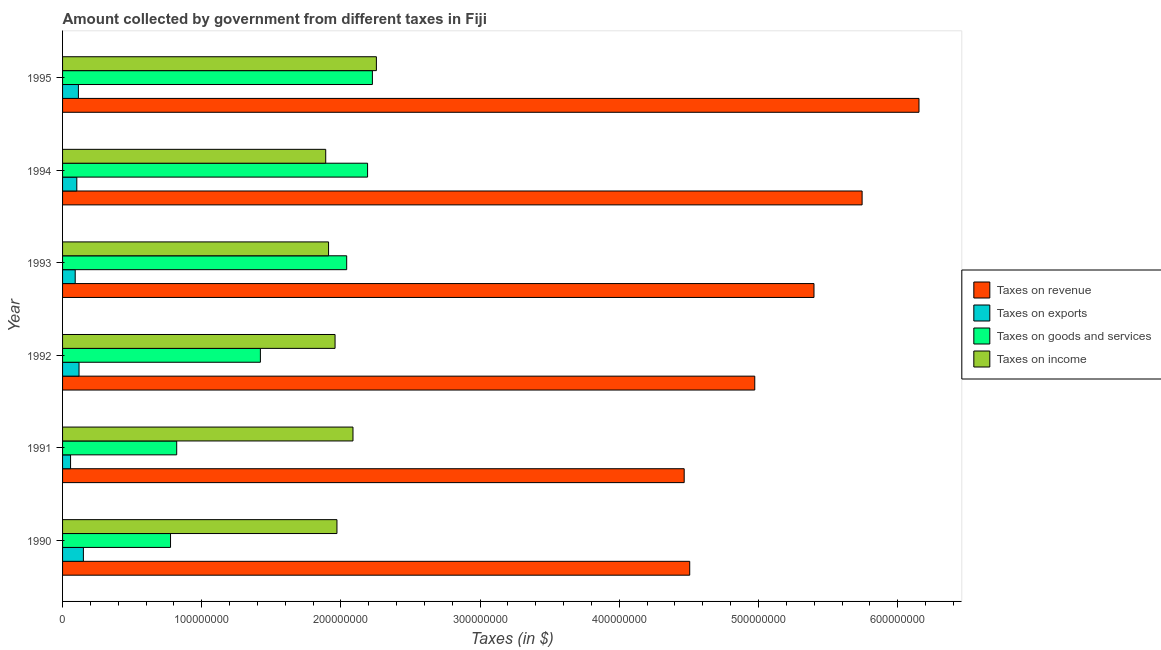How many groups of bars are there?
Offer a very short reply. 6. Are the number of bars on each tick of the Y-axis equal?
Provide a short and direct response. Yes. How many bars are there on the 4th tick from the bottom?
Give a very brief answer. 4. What is the amount collected as tax on exports in 1994?
Give a very brief answer. 1.02e+07. Across all years, what is the maximum amount collected as tax on exports?
Keep it short and to the point. 1.50e+07. Across all years, what is the minimum amount collected as tax on revenue?
Offer a very short reply. 4.47e+08. What is the total amount collected as tax on revenue in the graph?
Provide a succinct answer. 3.12e+09. What is the difference between the amount collected as tax on exports in 1990 and that in 1991?
Ensure brevity in your answer.  9.22e+06. What is the difference between the amount collected as tax on income in 1990 and the amount collected as tax on exports in 1992?
Offer a very short reply. 1.85e+08. What is the average amount collected as tax on goods per year?
Your response must be concise. 1.58e+08. In the year 1995, what is the difference between the amount collected as tax on revenue and amount collected as tax on exports?
Provide a succinct answer. 6.04e+08. What is the ratio of the amount collected as tax on exports in 1990 to that in 1992?
Ensure brevity in your answer.  1.26. Is the difference between the amount collected as tax on goods in 1990 and 1991 greater than the difference between the amount collected as tax on exports in 1990 and 1991?
Your response must be concise. No. What is the difference between the highest and the second highest amount collected as tax on exports?
Offer a very short reply. 3.13e+06. What is the difference between the highest and the lowest amount collected as tax on exports?
Give a very brief answer. 9.22e+06. Is the sum of the amount collected as tax on income in 1990 and 1991 greater than the maximum amount collected as tax on exports across all years?
Your answer should be very brief. Yes. Is it the case that in every year, the sum of the amount collected as tax on income and amount collected as tax on revenue is greater than the sum of amount collected as tax on exports and amount collected as tax on goods?
Your response must be concise. Yes. What does the 4th bar from the top in 1995 represents?
Keep it short and to the point. Taxes on revenue. What does the 3rd bar from the bottom in 1995 represents?
Your response must be concise. Taxes on goods and services. Is it the case that in every year, the sum of the amount collected as tax on revenue and amount collected as tax on exports is greater than the amount collected as tax on goods?
Provide a short and direct response. Yes. Are all the bars in the graph horizontal?
Your answer should be very brief. Yes. Does the graph contain any zero values?
Make the answer very short. No. Does the graph contain grids?
Provide a short and direct response. No. Where does the legend appear in the graph?
Offer a terse response. Center right. How many legend labels are there?
Your response must be concise. 4. How are the legend labels stacked?
Ensure brevity in your answer.  Vertical. What is the title of the graph?
Your response must be concise. Amount collected by government from different taxes in Fiji. What is the label or title of the X-axis?
Provide a succinct answer. Taxes (in $). What is the Taxes (in $) of Taxes on revenue in 1990?
Your response must be concise. 4.51e+08. What is the Taxes (in $) of Taxes on exports in 1990?
Offer a terse response. 1.50e+07. What is the Taxes (in $) of Taxes on goods and services in 1990?
Offer a very short reply. 7.76e+07. What is the Taxes (in $) in Taxes on income in 1990?
Your answer should be very brief. 1.97e+08. What is the Taxes (in $) of Taxes on revenue in 1991?
Offer a terse response. 4.47e+08. What is the Taxes (in $) of Taxes on exports in 1991?
Your answer should be very brief. 5.74e+06. What is the Taxes (in $) of Taxes on goods and services in 1991?
Ensure brevity in your answer.  8.20e+07. What is the Taxes (in $) in Taxes on income in 1991?
Keep it short and to the point. 2.09e+08. What is the Taxes (in $) of Taxes on revenue in 1992?
Provide a short and direct response. 4.97e+08. What is the Taxes (in $) in Taxes on exports in 1992?
Your response must be concise. 1.18e+07. What is the Taxes (in $) of Taxes on goods and services in 1992?
Offer a terse response. 1.42e+08. What is the Taxes (in $) of Taxes on income in 1992?
Give a very brief answer. 1.96e+08. What is the Taxes (in $) of Taxes on revenue in 1993?
Ensure brevity in your answer.  5.40e+08. What is the Taxes (in $) of Taxes on exports in 1993?
Your answer should be compact. 9.08e+06. What is the Taxes (in $) in Taxes on goods and services in 1993?
Keep it short and to the point. 2.04e+08. What is the Taxes (in $) of Taxes on income in 1993?
Provide a short and direct response. 1.91e+08. What is the Taxes (in $) of Taxes on revenue in 1994?
Keep it short and to the point. 5.74e+08. What is the Taxes (in $) in Taxes on exports in 1994?
Your answer should be very brief. 1.02e+07. What is the Taxes (in $) of Taxes on goods and services in 1994?
Your answer should be compact. 2.19e+08. What is the Taxes (in $) of Taxes on income in 1994?
Your response must be concise. 1.89e+08. What is the Taxes (in $) in Taxes on revenue in 1995?
Provide a short and direct response. 6.15e+08. What is the Taxes (in $) of Taxes on exports in 1995?
Ensure brevity in your answer.  1.14e+07. What is the Taxes (in $) in Taxes on goods and services in 1995?
Your answer should be compact. 2.23e+08. What is the Taxes (in $) of Taxes on income in 1995?
Keep it short and to the point. 2.25e+08. Across all years, what is the maximum Taxes (in $) in Taxes on revenue?
Your answer should be very brief. 6.15e+08. Across all years, what is the maximum Taxes (in $) of Taxes on exports?
Ensure brevity in your answer.  1.50e+07. Across all years, what is the maximum Taxes (in $) of Taxes on goods and services?
Your response must be concise. 2.23e+08. Across all years, what is the maximum Taxes (in $) in Taxes on income?
Make the answer very short. 2.25e+08. Across all years, what is the minimum Taxes (in $) in Taxes on revenue?
Offer a very short reply. 4.47e+08. Across all years, what is the minimum Taxes (in $) of Taxes on exports?
Ensure brevity in your answer.  5.74e+06. Across all years, what is the minimum Taxes (in $) of Taxes on goods and services?
Your answer should be compact. 7.76e+07. Across all years, what is the minimum Taxes (in $) in Taxes on income?
Your response must be concise. 1.89e+08. What is the total Taxes (in $) in Taxes on revenue in the graph?
Offer a terse response. 3.12e+09. What is the total Taxes (in $) of Taxes on exports in the graph?
Ensure brevity in your answer.  6.32e+07. What is the total Taxes (in $) of Taxes on goods and services in the graph?
Offer a very short reply. 9.48e+08. What is the total Taxes (in $) of Taxes on income in the graph?
Give a very brief answer. 1.21e+09. What is the difference between the Taxes (in $) of Taxes on revenue in 1990 and that in 1991?
Your answer should be compact. 3.97e+06. What is the difference between the Taxes (in $) in Taxes on exports in 1990 and that in 1991?
Keep it short and to the point. 9.22e+06. What is the difference between the Taxes (in $) in Taxes on goods and services in 1990 and that in 1991?
Provide a succinct answer. -4.43e+06. What is the difference between the Taxes (in $) in Taxes on income in 1990 and that in 1991?
Your answer should be very brief. -1.15e+07. What is the difference between the Taxes (in $) in Taxes on revenue in 1990 and that in 1992?
Your response must be concise. -4.67e+07. What is the difference between the Taxes (in $) in Taxes on exports in 1990 and that in 1992?
Provide a succinct answer. 3.13e+06. What is the difference between the Taxes (in $) of Taxes on goods and services in 1990 and that in 1992?
Your answer should be compact. -6.46e+07. What is the difference between the Taxes (in $) of Taxes on income in 1990 and that in 1992?
Offer a very short reply. 1.36e+06. What is the difference between the Taxes (in $) of Taxes on revenue in 1990 and that in 1993?
Make the answer very short. -8.93e+07. What is the difference between the Taxes (in $) in Taxes on exports in 1990 and that in 1993?
Offer a terse response. 5.88e+06. What is the difference between the Taxes (in $) in Taxes on goods and services in 1990 and that in 1993?
Make the answer very short. -1.27e+08. What is the difference between the Taxes (in $) in Taxes on income in 1990 and that in 1993?
Provide a succinct answer. 6.03e+06. What is the difference between the Taxes (in $) in Taxes on revenue in 1990 and that in 1994?
Your answer should be compact. -1.24e+08. What is the difference between the Taxes (in $) in Taxes on exports in 1990 and that in 1994?
Make the answer very short. 4.72e+06. What is the difference between the Taxes (in $) in Taxes on goods and services in 1990 and that in 1994?
Offer a very short reply. -1.42e+08. What is the difference between the Taxes (in $) in Taxes on income in 1990 and that in 1994?
Provide a succinct answer. 8.07e+06. What is the difference between the Taxes (in $) in Taxes on revenue in 1990 and that in 1995?
Provide a succinct answer. -1.65e+08. What is the difference between the Taxes (in $) in Taxes on exports in 1990 and that in 1995?
Offer a very short reply. 3.58e+06. What is the difference between the Taxes (in $) in Taxes on goods and services in 1990 and that in 1995?
Ensure brevity in your answer.  -1.45e+08. What is the difference between the Taxes (in $) in Taxes on income in 1990 and that in 1995?
Make the answer very short. -2.83e+07. What is the difference between the Taxes (in $) of Taxes on revenue in 1991 and that in 1992?
Provide a succinct answer. -5.07e+07. What is the difference between the Taxes (in $) of Taxes on exports in 1991 and that in 1992?
Your answer should be compact. -6.09e+06. What is the difference between the Taxes (in $) of Taxes on goods and services in 1991 and that in 1992?
Your answer should be very brief. -6.01e+07. What is the difference between the Taxes (in $) in Taxes on income in 1991 and that in 1992?
Provide a succinct answer. 1.29e+07. What is the difference between the Taxes (in $) of Taxes on revenue in 1991 and that in 1993?
Provide a short and direct response. -9.32e+07. What is the difference between the Taxes (in $) of Taxes on exports in 1991 and that in 1993?
Provide a succinct answer. -3.34e+06. What is the difference between the Taxes (in $) of Taxes on goods and services in 1991 and that in 1993?
Your answer should be compact. -1.22e+08. What is the difference between the Taxes (in $) in Taxes on income in 1991 and that in 1993?
Offer a very short reply. 1.76e+07. What is the difference between the Taxes (in $) of Taxes on revenue in 1991 and that in 1994?
Your answer should be compact. -1.28e+08. What is the difference between the Taxes (in $) of Taxes on exports in 1991 and that in 1994?
Your response must be concise. -4.50e+06. What is the difference between the Taxes (in $) in Taxes on goods and services in 1991 and that in 1994?
Give a very brief answer. -1.37e+08. What is the difference between the Taxes (in $) in Taxes on income in 1991 and that in 1994?
Offer a terse response. 1.96e+07. What is the difference between the Taxes (in $) of Taxes on revenue in 1991 and that in 1995?
Make the answer very short. -1.69e+08. What is the difference between the Taxes (in $) of Taxes on exports in 1991 and that in 1995?
Offer a terse response. -5.64e+06. What is the difference between the Taxes (in $) in Taxes on goods and services in 1991 and that in 1995?
Offer a terse response. -1.41e+08. What is the difference between the Taxes (in $) of Taxes on income in 1991 and that in 1995?
Ensure brevity in your answer.  -1.68e+07. What is the difference between the Taxes (in $) in Taxes on revenue in 1992 and that in 1993?
Your answer should be very brief. -4.26e+07. What is the difference between the Taxes (in $) in Taxes on exports in 1992 and that in 1993?
Offer a very short reply. 2.75e+06. What is the difference between the Taxes (in $) in Taxes on goods and services in 1992 and that in 1993?
Make the answer very short. -6.20e+07. What is the difference between the Taxes (in $) in Taxes on income in 1992 and that in 1993?
Offer a very short reply. 4.67e+06. What is the difference between the Taxes (in $) of Taxes on revenue in 1992 and that in 1994?
Offer a terse response. -7.71e+07. What is the difference between the Taxes (in $) in Taxes on exports in 1992 and that in 1994?
Keep it short and to the point. 1.59e+06. What is the difference between the Taxes (in $) of Taxes on goods and services in 1992 and that in 1994?
Offer a very short reply. -7.70e+07. What is the difference between the Taxes (in $) of Taxes on income in 1992 and that in 1994?
Provide a succinct answer. 6.71e+06. What is the difference between the Taxes (in $) of Taxes on revenue in 1992 and that in 1995?
Make the answer very short. -1.18e+08. What is the difference between the Taxes (in $) in Taxes on goods and services in 1992 and that in 1995?
Make the answer very short. -8.05e+07. What is the difference between the Taxes (in $) of Taxes on income in 1992 and that in 1995?
Offer a very short reply. -2.97e+07. What is the difference between the Taxes (in $) in Taxes on revenue in 1993 and that in 1994?
Offer a terse response. -3.46e+07. What is the difference between the Taxes (in $) of Taxes on exports in 1993 and that in 1994?
Give a very brief answer. -1.16e+06. What is the difference between the Taxes (in $) in Taxes on goods and services in 1993 and that in 1994?
Make the answer very short. -1.50e+07. What is the difference between the Taxes (in $) of Taxes on income in 1993 and that in 1994?
Your answer should be compact. 2.04e+06. What is the difference between the Taxes (in $) of Taxes on revenue in 1993 and that in 1995?
Ensure brevity in your answer.  -7.54e+07. What is the difference between the Taxes (in $) in Taxes on exports in 1993 and that in 1995?
Provide a succinct answer. -2.30e+06. What is the difference between the Taxes (in $) in Taxes on goods and services in 1993 and that in 1995?
Provide a succinct answer. -1.85e+07. What is the difference between the Taxes (in $) in Taxes on income in 1993 and that in 1995?
Give a very brief answer. -3.44e+07. What is the difference between the Taxes (in $) in Taxes on revenue in 1994 and that in 1995?
Ensure brevity in your answer.  -4.09e+07. What is the difference between the Taxes (in $) of Taxes on exports in 1994 and that in 1995?
Provide a succinct answer. -1.14e+06. What is the difference between the Taxes (in $) of Taxes on goods and services in 1994 and that in 1995?
Provide a succinct answer. -3.46e+06. What is the difference between the Taxes (in $) of Taxes on income in 1994 and that in 1995?
Offer a terse response. -3.64e+07. What is the difference between the Taxes (in $) of Taxes on revenue in 1990 and the Taxes (in $) of Taxes on exports in 1991?
Offer a very short reply. 4.45e+08. What is the difference between the Taxes (in $) of Taxes on revenue in 1990 and the Taxes (in $) of Taxes on goods and services in 1991?
Give a very brief answer. 3.69e+08. What is the difference between the Taxes (in $) in Taxes on revenue in 1990 and the Taxes (in $) in Taxes on income in 1991?
Offer a very short reply. 2.42e+08. What is the difference between the Taxes (in $) of Taxes on exports in 1990 and the Taxes (in $) of Taxes on goods and services in 1991?
Give a very brief answer. -6.70e+07. What is the difference between the Taxes (in $) of Taxes on exports in 1990 and the Taxes (in $) of Taxes on income in 1991?
Offer a very short reply. -1.94e+08. What is the difference between the Taxes (in $) in Taxes on goods and services in 1990 and the Taxes (in $) in Taxes on income in 1991?
Your answer should be compact. -1.31e+08. What is the difference between the Taxes (in $) in Taxes on revenue in 1990 and the Taxes (in $) in Taxes on exports in 1992?
Make the answer very short. 4.39e+08. What is the difference between the Taxes (in $) of Taxes on revenue in 1990 and the Taxes (in $) of Taxes on goods and services in 1992?
Offer a very short reply. 3.08e+08. What is the difference between the Taxes (in $) in Taxes on revenue in 1990 and the Taxes (in $) in Taxes on income in 1992?
Your answer should be very brief. 2.55e+08. What is the difference between the Taxes (in $) of Taxes on exports in 1990 and the Taxes (in $) of Taxes on goods and services in 1992?
Your answer should be compact. -1.27e+08. What is the difference between the Taxes (in $) of Taxes on exports in 1990 and the Taxes (in $) of Taxes on income in 1992?
Your answer should be very brief. -1.81e+08. What is the difference between the Taxes (in $) in Taxes on goods and services in 1990 and the Taxes (in $) in Taxes on income in 1992?
Ensure brevity in your answer.  -1.18e+08. What is the difference between the Taxes (in $) of Taxes on revenue in 1990 and the Taxes (in $) of Taxes on exports in 1993?
Give a very brief answer. 4.42e+08. What is the difference between the Taxes (in $) of Taxes on revenue in 1990 and the Taxes (in $) of Taxes on goods and services in 1993?
Make the answer very short. 2.46e+08. What is the difference between the Taxes (in $) of Taxes on revenue in 1990 and the Taxes (in $) of Taxes on income in 1993?
Your response must be concise. 2.59e+08. What is the difference between the Taxes (in $) in Taxes on exports in 1990 and the Taxes (in $) in Taxes on goods and services in 1993?
Give a very brief answer. -1.89e+08. What is the difference between the Taxes (in $) in Taxes on exports in 1990 and the Taxes (in $) in Taxes on income in 1993?
Your answer should be compact. -1.76e+08. What is the difference between the Taxes (in $) of Taxes on goods and services in 1990 and the Taxes (in $) of Taxes on income in 1993?
Make the answer very short. -1.14e+08. What is the difference between the Taxes (in $) in Taxes on revenue in 1990 and the Taxes (in $) in Taxes on exports in 1994?
Provide a short and direct response. 4.40e+08. What is the difference between the Taxes (in $) of Taxes on revenue in 1990 and the Taxes (in $) of Taxes on goods and services in 1994?
Keep it short and to the point. 2.31e+08. What is the difference between the Taxes (in $) in Taxes on revenue in 1990 and the Taxes (in $) in Taxes on income in 1994?
Provide a succinct answer. 2.62e+08. What is the difference between the Taxes (in $) of Taxes on exports in 1990 and the Taxes (in $) of Taxes on goods and services in 1994?
Make the answer very short. -2.04e+08. What is the difference between the Taxes (in $) of Taxes on exports in 1990 and the Taxes (in $) of Taxes on income in 1994?
Your answer should be very brief. -1.74e+08. What is the difference between the Taxes (in $) in Taxes on goods and services in 1990 and the Taxes (in $) in Taxes on income in 1994?
Keep it short and to the point. -1.12e+08. What is the difference between the Taxes (in $) of Taxes on revenue in 1990 and the Taxes (in $) of Taxes on exports in 1995?
Your answer should be compact. 4.39e+08. What is the difference between the Taxes (in $) in Taxes on revenue in 1990 and the Taxes (in $) in Taxes on goods and services in 1995?
Provide a short and direct response. 2.28e+08. What is the difference between the Taxes (in $) in Taxes on revenue in 1990 and the Taxes (in $) in Taxes on income in 1995?
Provide a short and direct response. 2.25e+08. What is the difference between the Taxes (in $) of Taxes on exports in 1990 and the Taxes (in $) of Taxes on goods and services in 1995?
Provide a succinct answer. -2.08e+08. What is the difference between the Taxes (in $) of Taxes on exports in 1990 and the Taxes (in $) of Taxes on income in 1995?
Make the answer very short. -2.11e+08. What is the difference between the Taxes (in $) of Taxes on goods and services in 1990 and the Taxes (in $) of Taxes on income in 1995?
Provide a succinct answer. -1.48e+08. What is the difference between the Taxes (in $) of Taxes on revenue in 1991 and the Taxes (in $) of Taxes on exports in 1992?
Provide a short and direct response. 4.35e+08. What is the difference between the Taxes (in $) of Taxes on revenue in 1991 and the Taxes (in $) of Taxes on goods and services in 1992?
Offer a very short reply. 3.04e+08. What is the difference between the Taxes (in $) of Taxes on revenue in 1991 and the Taxes (in $) of Taxes on income in 1992?
Your answer should be compact. 2.51e+08. What is the difference between the Taxes (in $) in Taxes on exports in 1991 and the Taxes (in $) in Taxes on goods and services in 1992?
Provide a succinct answer. -1.36e+08. What is the difference between the Taxes (in $) in Taxes on exports in 1991 and the Taxes (in $) in Taxes on income in 1992?
Keep it short and to the point. -1.90e+08. What is the difference between the Taxes (in $) in Taxes on goods and services in 1991 and the Taxes (in $) in Taxes on income in 1992?
Your response must be concise. -1.14e+08. What is the difference between the Taxes (in $) in Taxes on revenue in 1991 and the Taxes (in $) in Taxes on exports in 1993?
Provide a short and direct response. 4.38e+08. What is the difference between the Taxes (in $) of Taxes on revenue in 1991 and the Taxes (in $) of Taxes on goods and services in 1993?
Your response must be concise. 2.42e+08. What is the difference between the Taxes (in $) of Taxes on revenue in 1991 and the Taxes (in $) of Taxes on income in 1993?
Make the answer very short. 2.56e+08. What is the difference between the Taxes (in $) of Taxes on exports in 1991 and the Taxes (in $) of Taxes on goods and services in 1993?
Keep it short and to the point. -1.98e+08. What is the difference between the Taxes (in $) of Taxes on exports in 1991 and the Taxes (in $) of Taxes on income in 1993?
Offer a very short reply. -1.85e+08. What is the difference between the Taxes (in $) of Taxes on goods and services in 1991 and the Taxes (in $) of Taxes on income in 1993?
Ensure brevity in your answer.  -1.09e+08. What is the difference between the Taxes (in $) in Taxes on revenue in 1991 and the Taxes (in $) in Taxes on exports in 1994?
Your answer should be compact. 4.36e+08. What is the difference between the Taxes (in $) of Taxes on revenue in 1991 and the Taxes (in $) of Taxes on goods and services in 1994?
Your answer should be compact. 2.27e+08. What is the difference between the Taxes (in $) of Taxes on revenue in 1991 and the Taxes (in $) of Taxes on income in 1994?
Give a very brief answer. 2.58e+08. What is the difference between the Taxes (in $) of Taxes on exports in 1991 and the Taxes (in $) of Taxes on goods and services in 1994?
Give a very brief answer. -2.13e+08. What is the difference between the Taxes (in $) of Taxes on exports in 1991 and the Taxes (in $) of Taxes on income in 1994?
Provide a short and direct response. -1.83e+08. What is the difference between the Taxes (in $) of Taxes on goods and services in 1991 and the Taxes (in $) of Taxes on income in 1994?
Ensure brevity in your answer.  -1.07e+08. What is the difference between the Taxes (in $) of Taxes on revenue in 1991 and the Taxes (in $) of Taxes on exports in 1995?
Give a very brief answer. 4.35e+08. What is the difference between the Taxes (in $) of Taxes on revenue in 1991 and the Taxes (in $) of Taxes on goods and services in 1995?
Give a very brief answer. 2.24e+08. What is the difference between the Taxes (in $) of Taxes on revenue in 1991 and the Taxes (in $) of Taxes on income in 1995?
Keep it short and to the point. 2.21e+08. What is the difference between the Taxes (in $) in Taxes on exports in 1991 and the Taxes (in $) in Taxes on goods and services in 1995?
Your answer should be compact. -2.17e+08. What is the difference between the Taxes (in $) in Taxes on exports in 1991 and the Taxes (in $) in Taxes on income in 1995?
Provide a short and direct response. -2.20e+08. What is the difference between the Taxes (in $) of Taxes on goods and services in 1991 and the Taxes (in $) of Taxes on income in 1995?
Your answer should be compact. -1.43e+08. What is the difference between the Taxes (in $) of Taxes on revenue in 1992 and the Taxes (in $) of Taxes on exports in 1993?
Provide a succinct answer. 4.88e+08. What is the difference between the Taxes (in $) of Taxes on revenue in 1992 and the Taxes (in $) of Taxes on goods and services in 1993?
Offer a terse response. 2.93e+08. What is the difference between the Taxes (in $) in Taxes on revenue in 1992 and the Taxes (in $) in Taxes on income in 1993?
Ensure brevity in your answer.  3.06e+08. What is the difference between the Taxes (in $) of Taxes on exports in 1992 and the Taxes (in $) of Taxes on goods and services in 1993?
Ensure brevity in your answer.  -1.92e+08. What is the difference between the Taxes (in $) in Taxes on exports in 1992 and the Taxes (in $) in Taxes on income in 1993?
Your answer should be compact. -1.79e+08. What is the difference between the Taxes (in $) in Taxes on goods and services in 1992 and the Taxes (in $) in Taxes on income in 1993?
Keep it short and to the point. -4.90e+07. What is the difference between the Taxes (in $) in Taxes on revenue in 1992 and the Taxes (in $) in Taxes on exports in 1994?
Provide a short and direct response. 4.87e+08. What is the difference between the Taxes (in $) of Taxes on revenue in 1992 and the Taxes (in $) of Taxes on goods and services in 1994?
Make the answer very short. 2.78e+08. What is the difference between the Taxes (in $) in Taxes on revenue in 1992 and the Taxes (in $) in Taxes on income in 1994?
Your answer should be very brief. 3.08e+08. What is the difference between the Taxes (in $) of Taxes on exports in 1992 and the Taxes (in $) of Taxes on goods and services in 1994?
Ensure brevity in your answer.  -2.07e+08. What is the difference between the Taxes (in $) in Taxes on exports in 1992 and the Taxes (in $) in Taxes on income in 1994?
Offer a terse response. -1.77e+08. What is the difference between the Taxes (in $) in Taxes on goods and services in 1992 and the Taxes (in $) in Taxes on income in 1994?
Ensure brevity in your answer.  -4.69e+07. What is the difference between the Taxes (in $) of Taxes on revenue in 1992 and the Taxes (in $) of Taxes on exports in 1995?
Offer a terse response. 4.86e+08. What is the difference between the Taxes (in $) of Taxes on revenue in 1992 and the Taxes (in $) of Taxes on goods and services in 1995?
Offer a very short reply. 2.75e+08. What is the difference between the Taxes (in $) in Taxes on revenue in 1992 and the Taxes (in $) in Taxes on income in 1995?
Give a very brief answer. 2.72e+08. What is the difference between the Taxes (in $) in Taxes on exports in 1992 and the Taxes (in $) in Taxes on goods and services in 1995?
Your answer should be compact. -2.11e+08. What is the difference between the Taxes (in $) of Taxes on exports in 1992 and the Taxes (in $) of Taxes on income in 1995?
Ensure brevity in your answer.  -2.14e+08. What is the difference between the Taxes (in $) in Taxes on goods and services in 1992 and the Taxes (in $) in Taxes on income in 1995?
Offer a very short reply. -8.33e+07. What is the difference between the Taxes (in $) of Taxes on revenue in 1993 and the Taxes (in $) of Taxes on exports in 1994?
Your response must be concise. 5.30e+08. What is the difference between the Taxes (in $) in Taxes on revenue in 1993 and the Taxes (in $) in Taxes on goods and services in 1994?
Ensure brevity in your answer.  3.21e+08. What is the difference between the Taxes (in $) of Taxes on revenue in 1993 and the Taxes (in $) of Taxes on income in 1994?
Offer a terse response. 3.51e+08. What is the difference between the Taxes (in $) in Taxes on exports in 1993 and the Taxes (in $) in Taxes on goods and services in 1994?
Provide a succinct answer. -2.10e+08. What is the difference between the Taxes (in $) in Taxes on exports in 1993 and the Taxes (in $) in Taxes on income in 1994?
Provide a succinct answer. -1.80e+08. What is the difference between the Taxes (in $) of Taxes on goods and services in 1993 and the Taxes (in $) of Taxes on income in 1994?
Your answer should be compact. 1.51e+07. What is the difference between the Taxes (in $) of Taxes on revenue in 1993 and the Taxes (in $) of Taxes on exports in 1995?
Offer a terse response. 5.28e+08. What is the difference between the Taxes (in $) in Taxes on revenue in 1993 and the Taxes (in $) in Taxes on goods and services in 1995?
Your answer should be compact. 3.17e+08. What is the difference between the Taxes (in $) in Taxes on revenue in 1993 and the Taxes (in $) in Taxes on income in 1995?
Keep it short and to the point. 3.14e+08. What is the difference between the Taxes (in $) in Taxes on exports in 1993 and the Taxes (in $) in Taxes on goods and services in 1995?
Offer a terse response. -2.14e+08. What is the difference between the Taxes (in $) in Taxes on exports in 1993 and the Taxes (in $) in Taxes on income in 1995?
Your answer should be compact. -2.16e+08. What is the difference between the Taxes (in $) of Taxes on goods and services in 1993 and the Taxes (in $) of Taxes on income in 1995?
Keep it short and to the point. -2.13e+07. What is the difference between the Taxes (in $) of Taxes on revenue in 1994 and the Taxes (in $) of Taxes on exports in 1995?
Ensure brevity in your answer.  5.63e+08. What is the difference between the Taxes (in $) in Taxes on revenue in 1994 and the Taxes (in $) in Taxes on goods and services in 1995?
Offer a terse response. 3.52e+08. What is the difference between the Taxes (in $) in Taxes on revenue in 1994 and the Taxes (in $) in Taxes on income in 1995?
Keep it short and to the point. 3.49e+08. What is the difference between the Taxes (in $) in Taxes on exports in 1994 and the Taxes (in $) in Taxes on goods and services in 1995?
Ensure brevity in your answer.  -2.12e+08. What is the difference between the Taxes (in $) of Taxes on exports in 1994 and the Taxes (in $) of Taxes on income in 1995?
Your response must be concise. -2.15e+08. What is the difference between the Taxes (in $) of Taxes on goods and services in 1994 and the Taxes (in $) of Taxes on income in 1995?
Your answer should be compact. -6.33e+06. What is the average Taxes (in $) in Taxes on revenue per year?
Give a very brief answer. 5.21e+08. What is the average Taxes (in $) of Taxes on exports per year?
Offer a terse response. 1.05e+07. What is the average Taxes (in $) of Taxes on goods and services per year?
Give a very brief answer. 1.58e+08. What is the average Taxes (in $) in Taxes on income per year?
Offer a terse response. 2.01e+08. In the year 1990, what is the difference between the Taxes (in $) in Taxes on revenue and Taxes (in $) in Taxes on exports?
Provide a short and direct response. 4.36e+08. In the year 1990, what is the difference between the Taxes (in $) of Taxes on revenue and Taxes (in $) of Taxes on goods and services?
Your answer should be very brief. 3.73e+08. In the year 1990, what is the difference between the Taxes (in $) of Taxes on revenue and Taxes (in $) of Taxes on income?
Your answer should be compact. 2.53e+08. In the year 1990, what is the difference between the Taxes (in $) in Taxes on exports and Taxes (in $) in Taxes on goods and services?
Your answer should be very brief. -6.26e+07. In the year 1990, what is the difference between the Taxes (in $) in Taxes on exports and Taxes (in $) in Taxes on income?
Offer a terse response. -1.82e+08. In the year 1990, what is the difference between the Taxes (in $) of Taxes on goods and services and Taxes (in $) of Taxes on income?
Make the answer very short. -1.20e+08. In the year 1991, what is the difference between the Taxes (in $) in Taxes on revenue and Taxes (in $) in Taxes on exports?
Offer a terse response. 4.41e+08. In the year 1991, what is the difference between the Taxes (in $) of Taxes on revenue and Taxes (in $) of Taxes on goods and services?
Keep it short and to the point. 3.65e+08. In the year 1991, what is the difference between the Taxes (in $) in Taxes on revenue and Taxes (in $) in Taxes on income?
Your answer should be compact. 2.38e+08. In the year 1991, what is the difference between the Taxes (in $) in Taxes on exports and Taxes (in $) in Taxes on goods and services?
Ensure brevity in your answer.  -7.63e+07. In the year 1991, what is the difference between the Taxes (in $) in Taxes on exports and Taxes (in $) in Taxes on income?
Provide a short and direct response. -2.03e+08. In the year 1991, what is the difference between the Taxes (in $) of Taxes on goods and services and Taxes (in $) of Taxes on income?
Offer a terse response. -1.27e+08. In the year 1992, what is the difference between the Taxes (in $) in Taxes on revenue and Taxes (in $) in Taxes on exports?
Your answer should be compact. 4.85e+08. In the year 1992, what is the difference between the Taxes (in $) in Taxes on revenue and Taxes (in $) in Taxes on goods and services?
Keep it short and to the point. 3.55e+08. In the year 1992, what is the difference between the Taxes (in $) in Taxes on revenue and Taxes (in $) in Taxes on income?
Your answer should be compact. 3.02e+08. In the year 1992, what is the difference between the Taxes (in $) in Taxes on exports and Taxes (in $) in Taxes on goods and services?
Give a very brief answer. -1.30e+08. In the year 1992, what is the difference between the Taxes (in $) of Taxes on exports and Taxes (in $) of Taxes on income?
Keep it short and to the point. -1.84e+08. In the year 1992, what is the difference between the Taxes (in $) in Taxes on goods and services and Taxes (in $) in Taxes on income?
Your answer should be compact. -5.36e+07. In the year 1993, what is the difference between the Taxes (in $) of Taxes on revenue and Taxes (in $) of Taxes on exports?
Ensure brevity in your answer.  5.31e+08. In the year 1993, what is the difference between the Taxes (in $) of Taxes on revenue and Taxes (in $) of Taxes on goods and services?
Offer a very short reply. 3.36e+08. In the year 1993, what is the difference between the Taxes (in $) of Taxes on revenue and Taxes (in $) of Taxes on income?
Provide a succinct answer. 3.49e+08. In the year 1993, what is the difference between the Taxes (in $) of Taxes on exports and Taxes (in $) of Taxes on goods and services?
Your answer should be very brief. -1.95e+08. In the year 1993, what is the difference between the Taxes (in $) of Taxes on exports and Taxes (in $) of Taxes on income?
Your answer should be very brief. -1.82e+08. In the year 1993, what is the difference between the Taxes (in $) of Taxes on goods and services and Taxes (in $) of Taxes on income?
Make the answer very short. 1.30e+07. In the year 1994, what is the difference between the Taxes (in $) in Taxes on revenue and Taxes (in $) in Taxes on exports?
Keep it short and to the point. 5.64e+08. In the year 1994, what is the difference between the Taxes (in $) of Taxes on revenue and Taxes (in $) of Taxes on goods and services?
Offer a terse response. 3.55e+08. In the year 1994, what is the difference between the Taxes (in $) of Taxes on revenue and Taxes (in $) of Taxes on income?
Your answer should be compact. 3.85e+08. In the year 1994, what is the difference between the Taxes (in $) in Taxes on exports and Taxes (in $) in Taxes on goods and services?
Your answer should be very brief. -2.09e+08. In the year 1994, what is the difference between the Taxes (in $) in Taxes on exports and Taxes (in $) in Taxes on income?
Your response must be concise. -1.79e+08. In the year 1994, what is the difference between the Taxes (in $) in Taxes on goods and services and Taxes (in $) in Taxes on income?
Give a very brief answer. 3.01e+07. In the year 1995, what is the difference between the Taxes (in $) in Taxes on revenue and Taxes (in $) in Taxes on exports?
Give a very brief answer. 6.04e+08. In the year 1995, what is the difference between the Taxes (in $) in Taxes on revenue and Taxes (in $) in Taxes on goods and services?
Make the answer very short. 3.93e+08. In the year 1995, what is the difference between the Taxes (in $) in Taxes on revenue and Taxes (in $) in Taxes on income?
Ensure brevity in your answer.  3.90e+08. In the year 1995, what is the difference between the Taxes (in $) in Taxes on exports and Taxes (in $) in Taxes on goods and services?
Offer a terse response. -2.11e+08. In the year 1995, what is the difference between the Taxes (in $) of Taxes on exports and Taxes (in $) of Taxes on income?
Your answer should be very brief. -2.14e+08. In the year 1995, what is the difference between the Taxes (in $) in Taxes on goods and services and Taxes (in $) in Taxes on income?
Make the answer very short. -2.87e+06. What is the ratio of the Taxes (in $) in Taxes on revenue in 1990 to that in 1991?
Give a very brief answer. 1.01. What is the ratio of the Taxes (in $) of Taxes on exports in 1990 to that in 1991?
Your answer should be very brief. 2.61. What is the ratio of the Taxes (in $) in Taxes on goods and services in 1990 to that in 1991?
Provide a short and direct response. 0.95. What is the ratio of the Taxes (in $) of Taxes on income in 1990 to that in 1991?
Keep it short and to the point. 0.94. What is the ratio of the Taxes (in $) of Taxes on revenue in 1990 to that in 1992?
Provide a short and direct response. 0.91. What is the ratio of the Taxes (in $) of Taxes on exports in 1990 to that in 1992?
Ensure brevity in your answer.  1.26. What is the ratio of the Taxes (in $) in Taxes on goods and services in 1990 to that in 1992?
Your answer should be compact. 0.55. What is the ratio of the Taxes (in $) in Taxes on revenue in 1990 to that in 1993?
Offer a terse response. 0.83. What is the ratio of the Taxes (in $) in Taxes on exports in 1990 to that in 1993?
Provide a succinct answer. 1.65. What is the ratio of the Taxes (in $) of Taxes on goods and services in 1990 to that in 1993?
Your response must be concise. 0.38. What is the ratio of the Taxes (in $) of Taxes on income in 1990 to that in 1993?
Offer a terse response. 1.03. What is the ratio of the Taxes (in $) in Taxes on revenue in 1990 to that in 1994?
Keep it short and to the point. 0.78. What is the ratio of the Taxes (in $) of Taxes on exports in 1990 to that in 1994?
Your response must be concise. 1.46. What is the ratio of the Taxes (in $) in Taxes on goods and services in 1990 to that in 1994?
Give a very brief answer. 0.35. What is the ratio of the Taxes (in $) in Taxes on income in 1990 to that in 1994?
Offer a terse response. 1.04. What is the ratio of the Taxes (in $) in Taxes on revenue in 1990 to that in 1995?
Offer a terse response. 0.73. What is the ratio of the Taxes (in $) of Taxes on exports in 1990 to that in 1995?
Provide a succinct answer. 1.31. What is the ratio of the Taxes (in $) of Taxes on goods and services in 1990 to that in 1995?
Keep it short and to the point. 0.35. What is the ratio of the Taxes (in $) of Taxes on income in 1990 to that in 1995?
Keep it short and to the point. 0.87. What is the ratio of the Taxes (in $) in Taxes on revenue in 1991 to that in 1992?
Make the answer very short. 0.9. What is the ratio of the Taxes (in $) of Taxes on exports in 1991 to that in 1992?
Your answer should be compact. 0.49. What is the ratio of the Taxes (in $) in Taxes on goods and services in 1991 to that in 1992?
Offer a very short reply. 0.58. What is the ratio of the Taxes (in $) in Taxes on income in 1991 to that in 1992?
Provide a short and direct response. 1.07. What is the ratio of the Taxes (in $) of Taxes on revenue in 1991 to that in 1993?
Ensure brevity in your answer.  0.83. What is the ratio of the Taxes (in $) in Taxes on exports in 1991 to that in 1993?
Your answer should be very brief. 0.63. What is the ratio of the Taxes (in $) of Taxes on goods and services in 1991 to that in 1993?
Keep it short and to the point. 0.4. What is the ratio of the Taxes (in $) in Taxes on income in 1991 to that in 1993?
Your answer should be compact. 1.09. What is the ratio of the Taxes (in $) of Taxes on revenue in 1991 to that in 1994?
Offer a terse response. 0.78. What is the ratio of the Taxes (in $) in Taxes on exports in 1991 to that in 1994?
Your answer should be compact. 0.56. What is the ratio of the Taxes (in $) of Taxes on goods and services in 1991 to that in 1994?
Offer a terse response. 0.37. What is the ratio of the Taxes (in $) in Taxes on income in 1991 to that in 1994?
Your answer should be very brief. 1.1. What is the ratio of the Taxes (in $) in Taxes on revenue in 1991 to that in 1995?
Provide a short and direct response. 0.73. What is the ratio of the Taxes (in $) in Taxes on exports in 1991 to that in 1995?
Your response must be concise. 0.5. What is the ratio of the Taxes (in $) of Taxes on goods and services in 1991 to that in 1995?
Offer a terse response. 0.37. What is the ratio of the Taxes (in $) of Taxes on income in 1991 to that in 1995?
Your answer should be compact. 0.93. What is the ratio of the Taxes (in $) in Taxes on revenue in 1992 to that in 1993?
Ensure brevity in your answer.  0.92. What is the ratio of the Taxes (in $) in Taxes on exports in 1992 to that in 1993?
Your response must be concise. 1.3. What is the ratio of the Taxes (in $) of Taxes on goods and services in 1992 to that in 1993?
Keep it short and to the point. 0.7. What is the ratio of the Taxes (in $) of Taxes on income in 1992 to that in 1993?
Provide a succinct answer. 1.02. What is the ratio of the Taxes (in $) of Taxes on revenue in 1992 to that in 1994?
Give a very brief answer. 0.87. What is the ratio of the Taxes (in $) in Taxes on exports in 1992 to that in 1994?
Provide a succinct answer. 1.16. What is the ratio of the Taxes (in $) in Taxes on goods and services in 1992 to that in 1994?
Give a very brief answer. 0.65. What is the ratio of the Taxes (in $) of Taxes on income in 1992 to that in 1994?
Provide a succinct answer. 1.04. What is the ratio of the Taxes (in $) in Taxes on revenue in 1992 to that in 1995?
Give a very brief answer. 0.81. What is the ratio of the Taxes (in $) in Taxes on exports in 1992 to that in 1995?
Provide a short and direct response. 1.04. What is the ratio of the Taxes (in $) of Taxes on goods and services in 1992 to that in 1995?
Ensure brevity in your answer.  0.64. What is the ratio of the Taxes (in $) of Taxes on income in 1992 to that in 1995?
Offer a terse response. 0.87. What is the ratio of the Taxes (in $) in Taxes on revenue in 1993 to that in 1994?
Your answer should be compact. 0.94. What is the ratio of the Taxes (in $) of Taxes on exports in 1993 to that in 1994?
Your response must be concise. 0.89. What is the ratio of the Taxes (in $) in Taxes on goods and services in 1993 to that in 1994?
Ensure brevity in your answer.  0.93. What is the ratio of the Taxes (in $) of Taxes on income in 1993 to that in 1994?
Your answer should be compact. 1.01. What is the ratio of the Taxes (in $) of Taxes on revenue in 1993 to that in 1995?
Keep it short and to the point. 0.88. What is the ratio of the Taxes (in $) of Taxes on exports in 1993 to that in 1995?
Your answer should be very brief. 0.8. What is the ratio of the Taxes (in $) in Taxes on goods and services in 1993 to that in 1995?
Keep it short and to the point. 0.92. What is the ratio of the Taxes (in $) of Taxes on income in 1993 to that in 1995?
Provide a succinct answer. 0.85. What is the ratio of the Taxes (in $) in Taxes on revenue in 1994 to that in 1995?
Provide a short and direct response. 0.93. What is the ratio of the Taxes (in $) of Taxes on exports in 1994 to that in 1995?
Give a very brief answer. 0.9. What is the ratio of the Taxes (in $) in Taxes on goods and services in 1994 to that in 1995?
Ensure brevity in your answer.  0.98. What is the ratio of the Taxes (in $) of Taxes on income in 1994 to that in 1995?
Your response must be concise. 0.84. What is the difference between the highest and the second highest Taxes (in $) of Taxes on revenue?
Your response must be concise. 4.09e+07. What is the difference between the highest and the second highest Taxes (in $) in Taxes on exports?
Keep it short and to the point. 3.13e+06. What is the difference between the highest and the second highest Taxes (in $) of Taxes on goods and services?
Make the answer very short. 3.46e+06. What is the difference between the highest and the second highest Taxes (in $) of Taxes on income?
Your answer should be compact. 1.68e+07. What is the difference between the highest and the lowest Taxes (in $) in Taxes on revenue?
Ensure brevity in your answer.  1.69e+08. What is the difference between the highest and the lowest Taxes (in $) in Taxes on exports?
Ensure brevity in your answer.  9.22e+06. What is the difference between the highest and the lowest Taxes (in $) in Taxes on goods and services?
Your response must be concise. 1.45e+08. What is the difference between the highest and the lowest Taxes (in $) of Taxes on income?
Ensure brevity in your answer.  3.64e+07. 